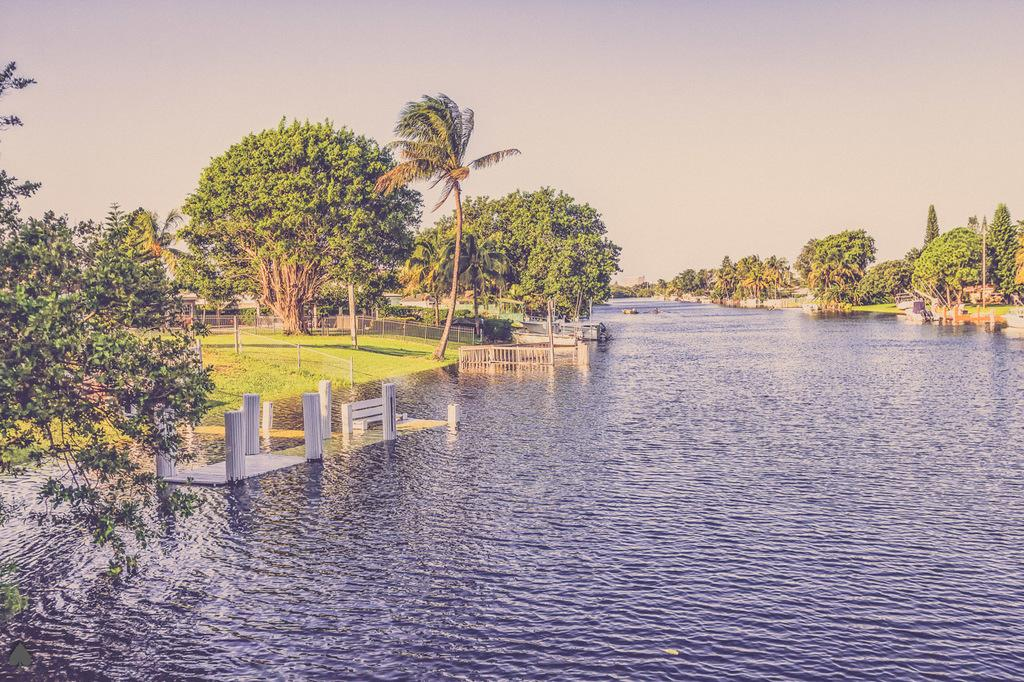What is visible in the image that is not solid? There is water visible in the image. What structures can be seen in the image? There are poles and a railing present in the image. What type of vegetation is visible in the image? There are green and brown trees in the image. What is visible in the background of the image? The sky is visible in the background of the image. Can you see any jewels or giraffes in the image? No, there are no jewels or giraffes present in the image. What type of death is depicted in the image? There is no depiction of death in the image; it features water, poles, a railing, trees, and the sky. 